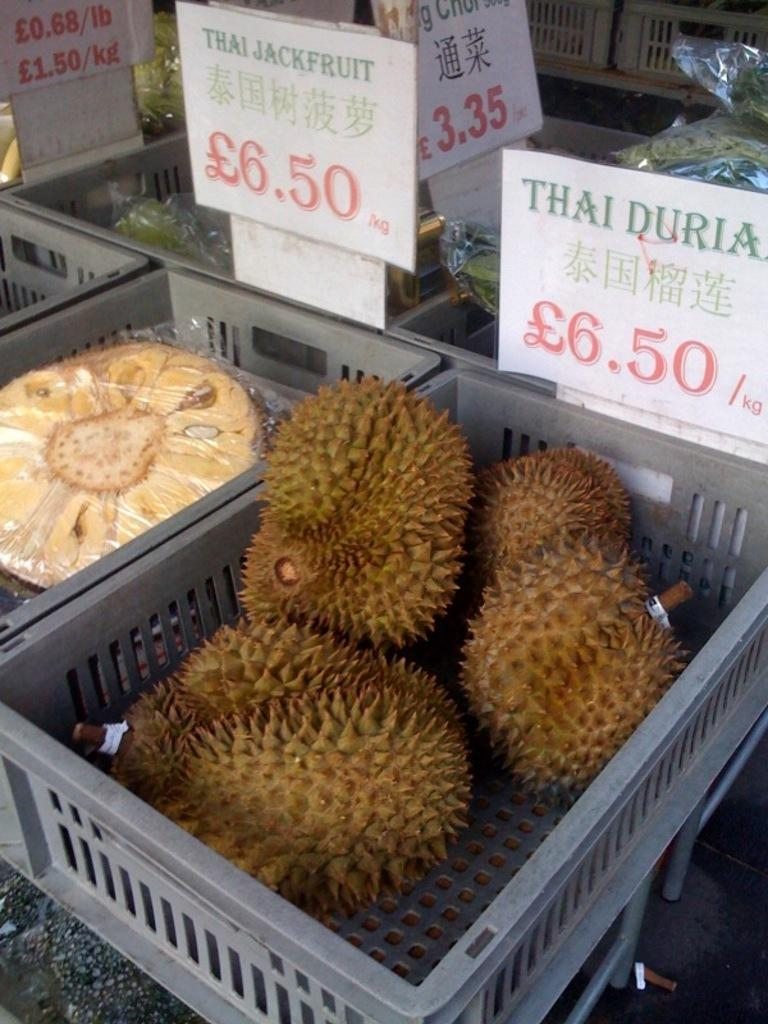What type of food can be seen in the image? There are fruits in trays in the image. What information might be available to customers in the image? There are price boards in the image, which may display the cost of the fruits. What advice is being given to the fruits in the image? There is no advice being given to the fruits in the image; they are simply displayed in trays. 